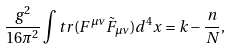Convert formula to latex. <formula><loc_0><loc_0><loc_500><loc_500>\frac { g ^ { 2 } } { 1 6 \pi ^ { 2 } } \int t r ( F ^ { \mu \nu } \tilde { F } _ { \mu \nu } ) d ^ { 4 } x = k - \frac { n } { N } ,</formula> 